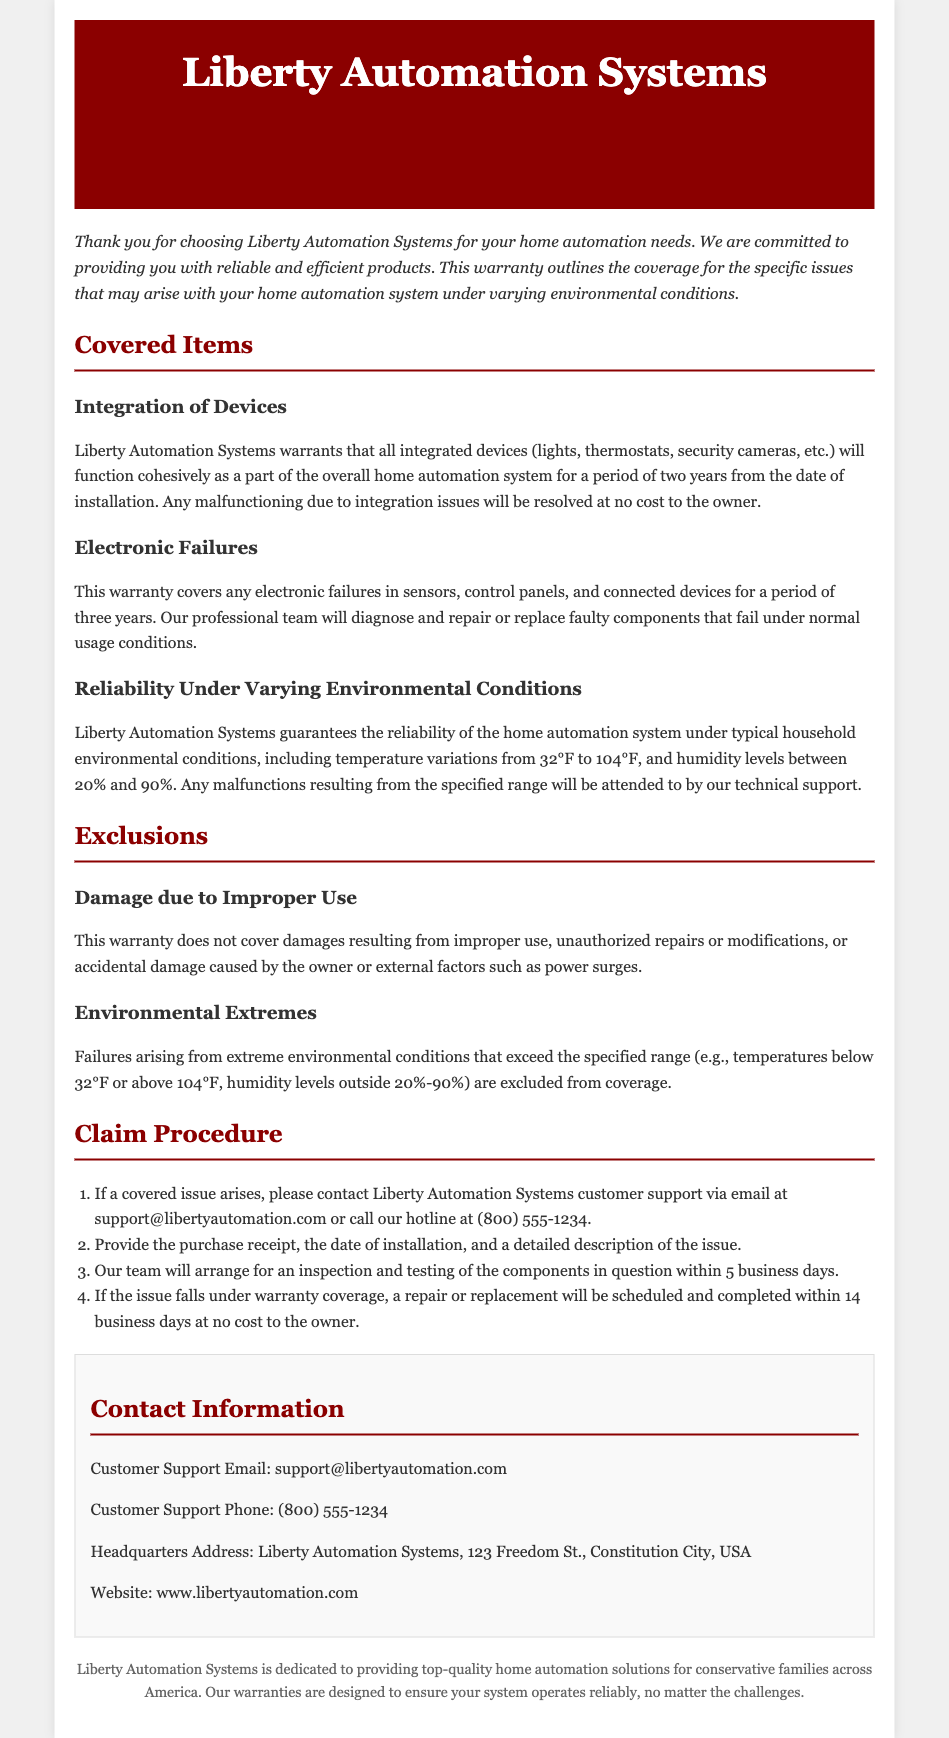what is the warranty period for integration issues? The warranty covers integration issues for a period of two years from the date of installation.
Answer: two years how long does the warranty cover electronic failures? The warranty covers electronic failures for a period of three years.
Answer: three years what are the typical household temperature conditions covered by the warranty? The warranty covers temperature variations from 32°F to 104°F.
Answer: 32°F to 104°F is damage due to improper use covered by the warranty? The warranty explicitly states that damages resulting from improper use are not covered.
Answer: no what should a customer provide when making a warranty claim? A customer should provide the purchase receipt, the date of installation, and a detailed description of the issue.
Answer: purchase receipt, date of installation, detailed description which humidity levels are covered under the warranty? The warranty covers humidity levels between 20% and 90%.
Answer: 20% and 90% how quickly will Liberty Automation Systems arrange for an inspection? Liberty Automation Systems will arrange for an inspection within 5 business days.
Answer: 5 business days what is excluded from the warranty in terms of environmental conditions? Failures arising from temperatures below 32°F or above 104°F, and humidity levels outside 20%-90% are excluded.
Answer: environmental extremes what is the contact email for customer support? The customer support email is provided in the contact information section.
Answer: support@libertyautomation.com 